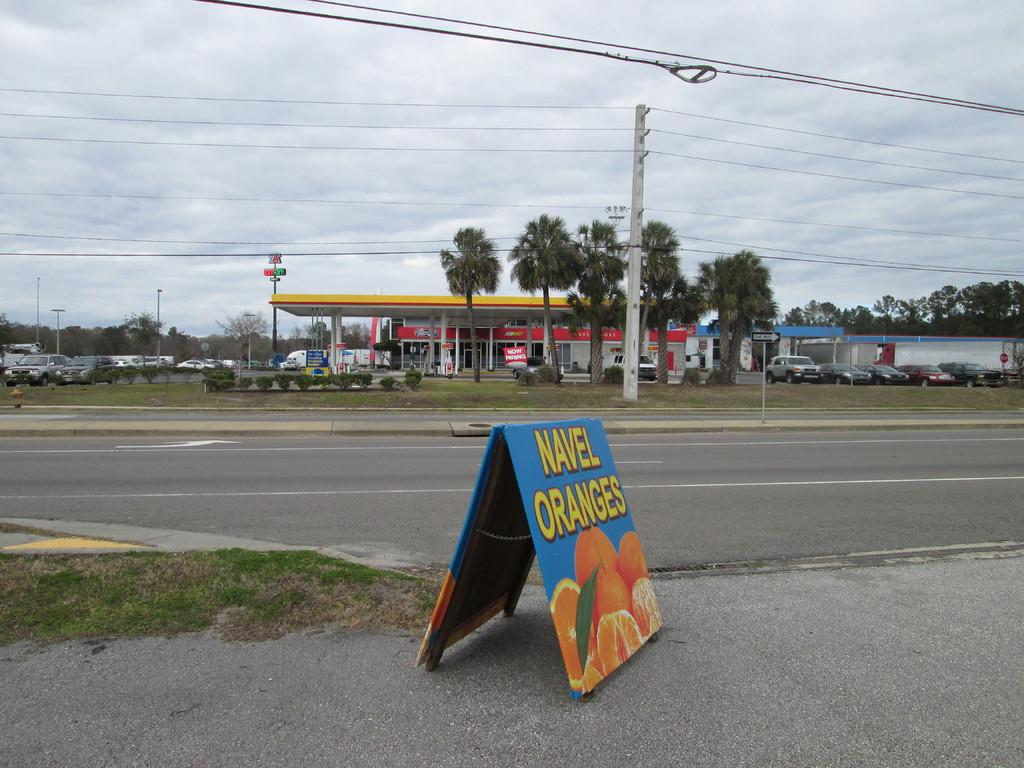<image>
Share a concise interpretation of the image provided. A folding sign of Navel Oranges is across the street from a gas station. 